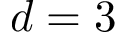<formula> <loc_0><loc_0><loc_500><loc_500>d = 3</formula> 